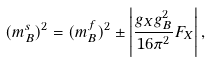<formula> <loc_0><loc_0><loc_500><loc_500>( m _ { B } ^ { s } ) ^ { 2 } = ( m _ { B } ^ { f } ) ^ { 2 } \pm \left | \frac { g _ { X } g _ { B } ^ { 2 } } { 1 6 \pi ^ { 2 } } F _ { X } \right | ,</formula> 